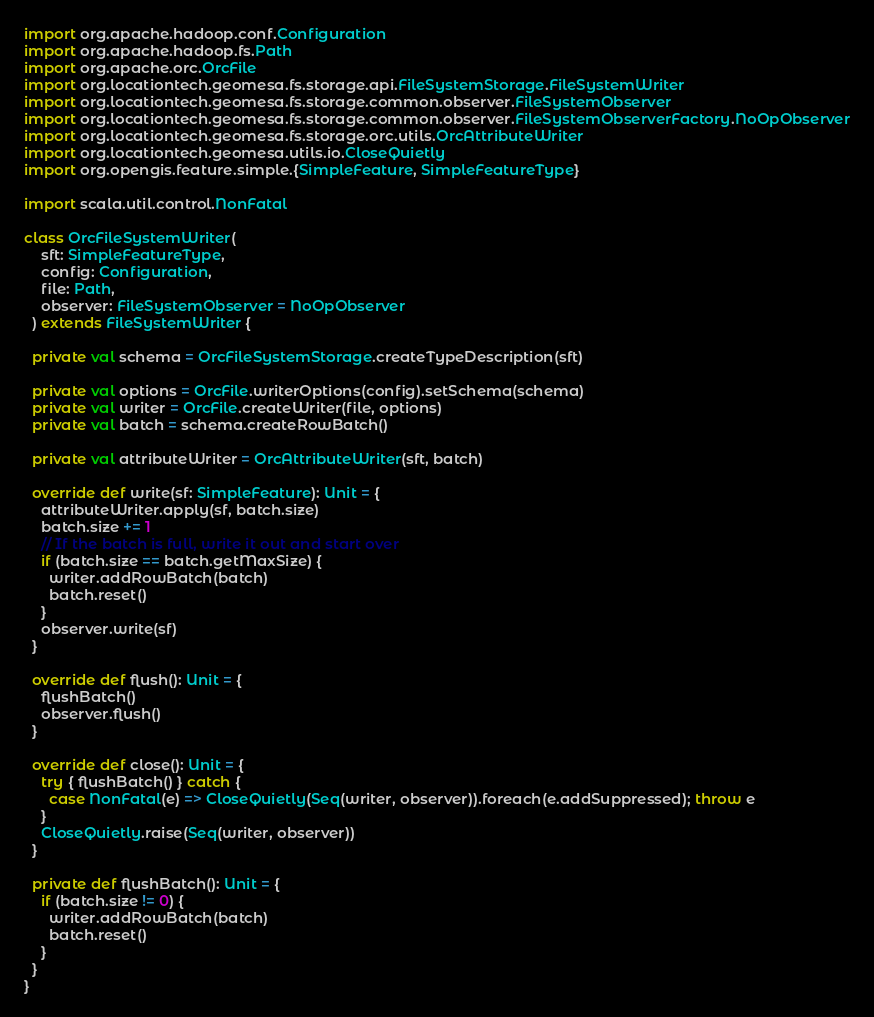<code> <loc_0><loc_0><loc_500><loc_500><_Scala_>import org.apache.hadoop.conf.Configuration
import org.apache.hadoop.fs.Path
import org.apache.orc.OrcFile
import org.locationtech.geomesa.fs.storage.api.FileSystemStorage.FileSystemWriter
import org.locationtech.geomesa.fs.storage.common.observer.FileSystemObserver
import org.locationtech.geomesa.fs.storage.common.observer.FileSystemObserverFactory.NoOpObserver
import org.locationtech.geomesa.fs.storage.orc.utils.OrcAttributeWriter
import org.locationtech.geomesa.utils.io.CloseQuietly
import org.opengis.feature.simple.{SimpleFeature, SimpleFeatureType}

import scala.util.control.NonFatal

class OrcFileSystemWriter(
    sft: SimpleFeatureType,
    config: Configuration,
    file: Path,
    observer: FileSystemObserver = NoOpObserver
  ) extends FileSystemWriter {

  private val schema = OrcFileSystemStorage.createTypeDescription(sft)

  private val options = OrcFile.writerOptions(config).setSchema(schema)
  private val writer = OrcFile.createWriter(file, options)
  private val batch = schema.createRowBatch()

  private val attributeWriter = OrcAttributeWriter(sft, batch)

  override def write(sf: SimpleFeature): Unit = {
    attributeWriter.apply(sf, batch.size)
    batch.size += 1
    // If the batch is full, write it out and start over
    if (batch.size == batch.getMaxSize) {
      writer.addRowBatch(batch)
      batch.reset()
    }
    observer.write(sf)
  }

  override def flush(): Unit = {
    flushBatch()
    observer.flush()
  }

  override def close(): Unit = {
    try { flushBatch() } catch {
      case NonFatal(e) => CloseQuietly(Seq(writer, observer)).foreach(e.addSuppressed); throw e
    }
    CloseQuietly.raise(Seq(writer, observer))
  }

  private def flushBatch(): Unit = {
    if (batch.size != 0) {
      writer.addRowBatch(batch)
      batch.reset()
    }
  }
}
</code> 